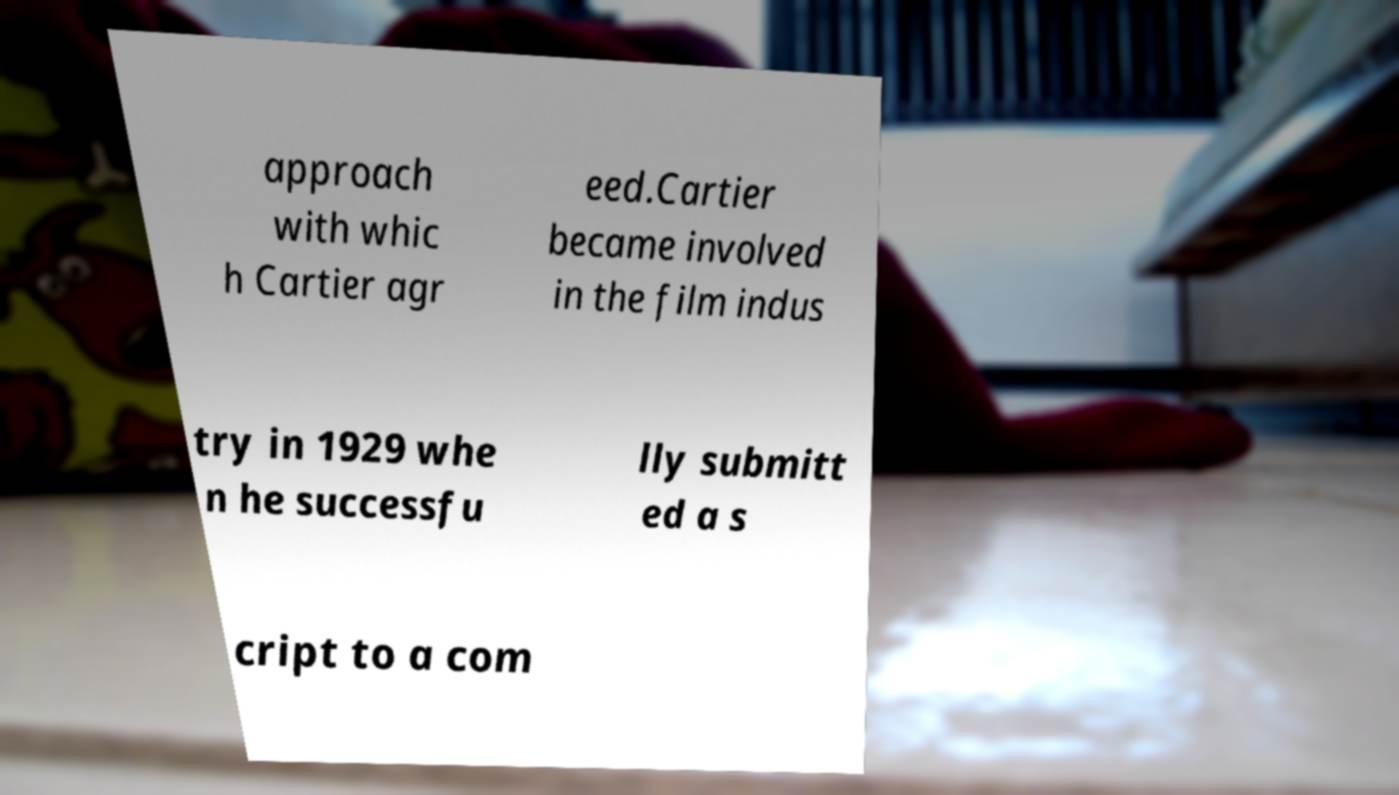Can you read and provide the text displayed in the image?This photo seems to have some interesting text. Can you extract and type it out for me? approach with whic h Cartier agr eed.Cartier became involved in the film indus try in 1929 whe n he successfu lly submitt ed a s cript to a com 